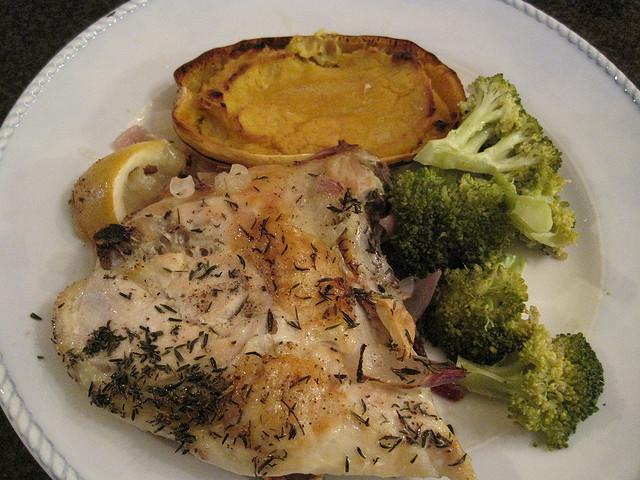What color is the plate?
Be succinct. White. What is the white meat?
Keep it brief. Chicken. Does the plate contain meat?
Give a very brief answer. Yes. Is this a vegetarian meal?
Keep it brief. No. Is this variation one that would be considered a meat-lovers variation?
Keep it brief. Yes. What is the green stuff on the food item?
Short answer required. Broccoli. Is that salmon?
Write a very short answer. No. Would a vegan eat this?
Write a very short answer. No. What is the orange food?
Give a very brief answer. Potato. Would a vegetarian eat this?
Quick response, please. No. What is the green vegetable?
Be succinct. Broccoli. What is the small yellow wedge?
Be succinct. Lemon. Is that chicken or fish?
Give a very brief answer. Chicken. Is this food healthy?
Be succinct. Yes. What kind of food is on the white plate?
Write a very short answer. Chicken and broccoli. What kind of meat is this?
Keep it brief. Chicken. What kinds of vegetables are in the picture?
Short answer required. Broccoli. Are there carrots in this dish?
Concise answer only. No. Is there any sauce on the plate?
Quick response, please. No. Is this sweet or savory?
Keep it brief. Savory. Is there pasta in this dish?
Short answer required. No. Does this meal look delicious?
Be succinct. Yes. Is there carrots in this dish?
Keep it brief. No. What type of cuisine does this represent?
Keep it brief. Dinner. Is there meat on the plate?
Concise answer only. Yes. Is this a balanced meal?
Keep it brief. Yes. 